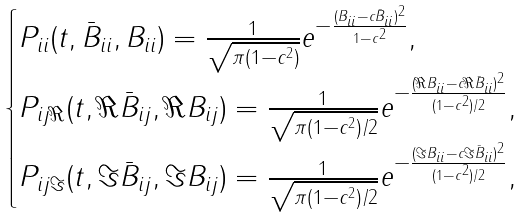<formula> <loc_0><loc_0><loc_500><loc_500>\begin{cases} P _ { i i } ( t , \bar { B } _ { i i } , B _ { i i } ) = \frac { 1 } { \sqrt { \pi ( 1 - c ^ { 2 } ) } } e ^ { - \frac { ( B _ { i i } - c \bar { B } _ { i i } ) ^ { 2 } } { 1 - c ^ { 2 } } } , \\ P _ { i j \Re } ( t , \Re \bar { B } _ { i j } , \Re B _ { i j } ) = \frac { 1 } { \sqrt { \pi ( 1 - c ^ { 2 } ) / 2 } } e ^ { - \frac { ( \Re B _ { i i } - c \Re \bar { B } _ { i i } ) ^ { 2 } } { ( 1 - c ^ { 2 } ) / 2 } } , \\ P _ { i j \Im } ( t , \Im \bar { B } _ { i j } , \Im B _ { i j } ) = \frac { 1 } { \sqrt { \pi ( 1 - c ^ { 2 } ) / 2 } } e ^ { - \frac { ( \Im B _ { i i } - c \Im \bar { B } _ { i i } ) ^ { 2 } } { ( 1 - c ^ { 2 } ) / 2 } } , \end{cases}</formula> 